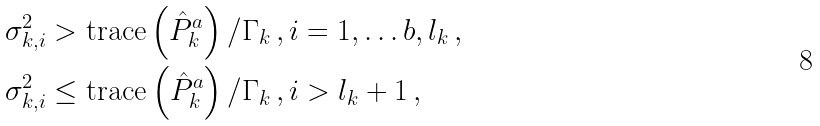Convert formula to latex. <formula><loc_0><loc_0><loc_500><loc_500>& \sigma _ { k , i } ^ { 2 } > \text {trace} \left ( \hat { P } _ { k } ^ { a } \right ) / \Gamma _ { k } \, , i = 1 , \dots b , l _ { k } \, , \\ & \sigma _ { k , i } ^ { 2 } \leq \text {trace} \left ( \hat { P } _ { k } ^ { a } \right ) / \Gamma _ { k } \, , i > l _ { k } + 1 \, ,</formula> 